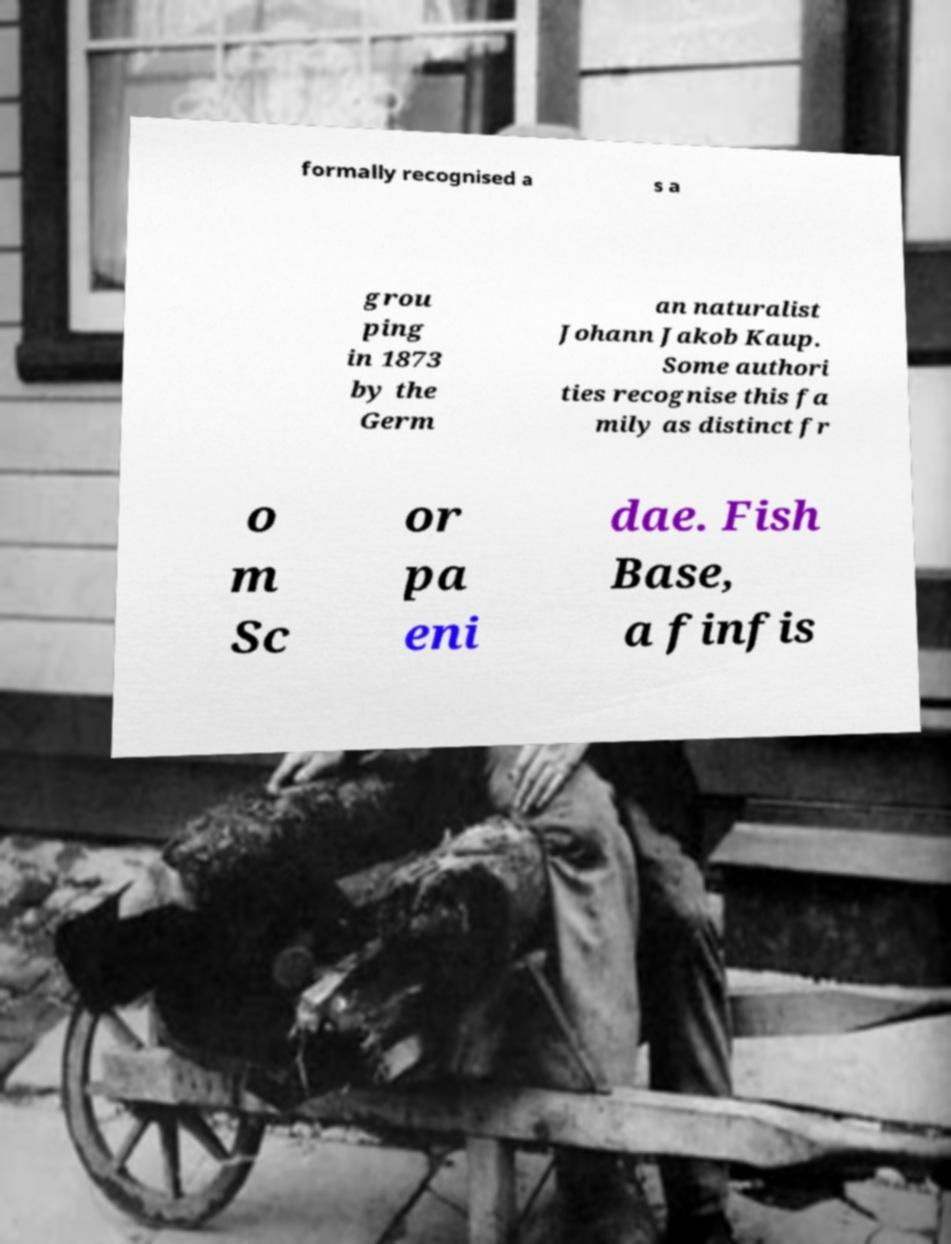Please identify and transcribe the text found in this image. formally recognised a s a grou ping in 1873 by the Germ an naturalist Johann Jakob Kaup. Some authori ties recognise this fa mily as distinct fr o m Sc or pa eni dae. Fish Base, a finfis 